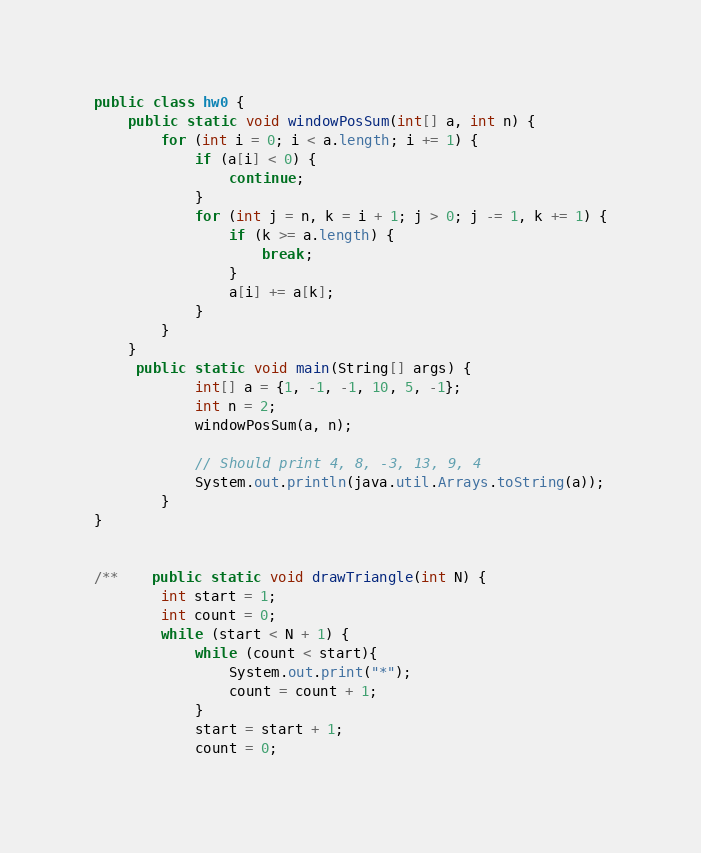Convert code to text. <code><loc_0><loc_0><loc_500><loc_500><_Java_>public class hw0 {
    public static void windowPosSum(int[] a, int n) {
        for (int i = 0; i < a.length; i += 1) {
            if (a[i] < 0) {
                continue;
            }
            for (int j = n, k = i + 1; j > 0; j -= 1, k += 1) {
                if (k >= a.length) {
                    break;
                }
                a[i] += a[k];
            }
        }
    }
     public static void main(String[] args) {
            int[] a = {1, -1, -1, 10, 5, -1};
            int n = 2;
            windowPosSum(a, n);

            // Should print 4, 8, -3, 13, 9, 4
            System.out.println(java.util.Arrays.toString(a));
        }
}


/**    public static void drawTriangle(int N) {
        int start = 1;
        int count = 0;
        while (start < N + 1) {
            while (count < start){
                System.out.print("*");
                count = count + 1;
            }
            start = start + 1;
            count = 0;</code> 